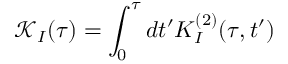Convert formula to latex. <formula><loc_0><loc_0><loc_500><loc_500>\mathcal { K } _ { I } ( \tau ) = \int _ { 0 } ^ { \tau } d t ^ { \prime } K _ { I } ^ { ( 2 ) } ( \tau , t ^ { \prime } )</formula> 